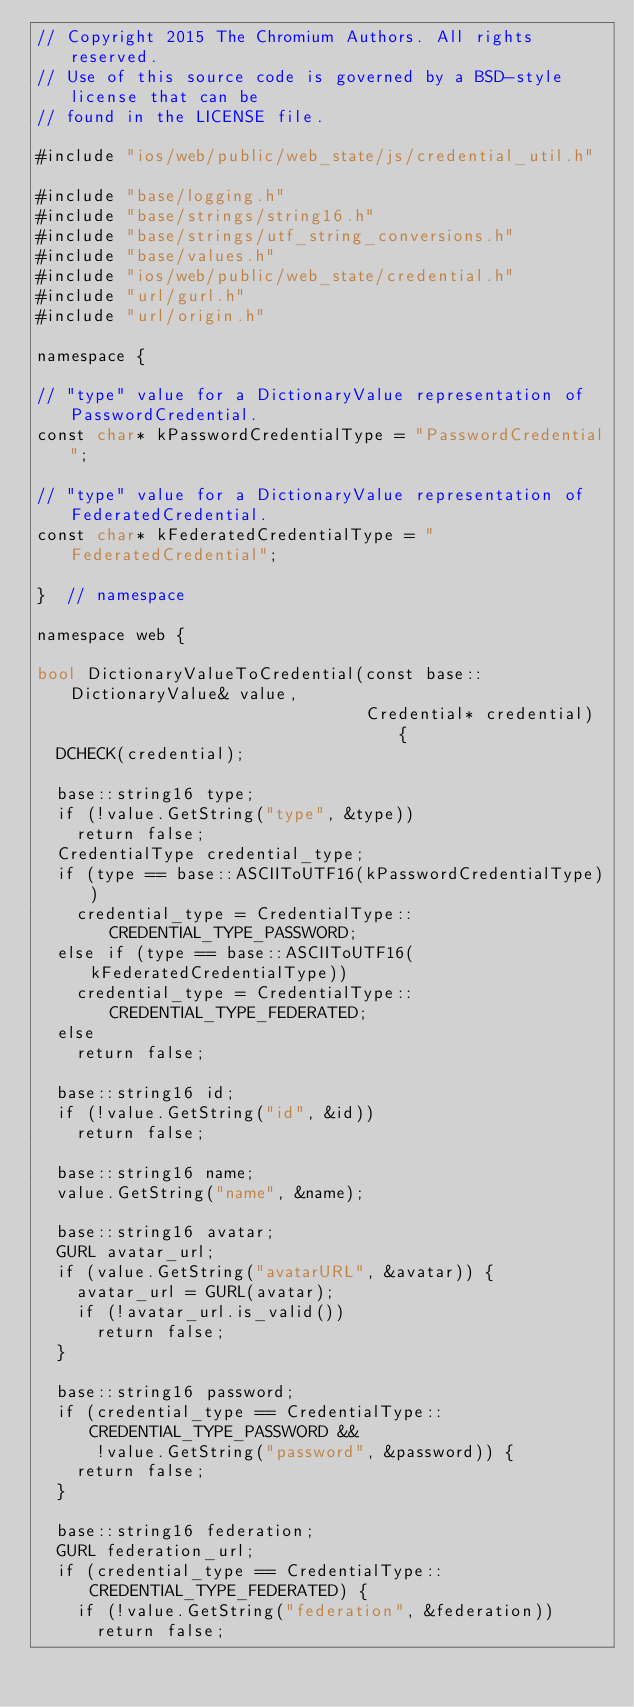<code> <loc_0><loc_0><loc_500><loc_500><_ObjectiveC_>// Copyright 2015 The Chromium Authors. All rights reserved.
// Use of this source code is governed by a BSD-style license that can be
// found in the LICENSE file.

#include "ios/web/public/web_state/js/credential_util.h"

#include "base/logging.h"
#include "base/strings/string16.h"
#include "base/strings/utf_string_conversions.h"
#include "base/values.h"
#include "ios/web/public/web_state/credential.h"
#include "url/gurl.h"
#include "url/origin.h"

namespace {

// "type" value for a DictionaryValue representation of PasswordCredential.
const char* kPasswordCredentialType = "PasswordCredential";

// "type" value for a DictionaryValue representation of FederatedCredential.
const char* kFederatedCredentialType = "FederatedCredential";

}  // namespace

namespace web {

bool DictionaryValueToCredential(const base::DictionaryValue& value,
                                 Credential* credential) {
  DCHECK(credential);

  base::string16 type;
  if (!value.GetString("type", &type))
    return false;
  CredentialType credential_type;
  if (type == base::ASCIIToUTF16(kPasswordCredentialType))
    credential_type = CredentialType::CREDENTIAL_TYPE_PASSWORD;
  else if (type == base::ASCIIToUTF16(kFederatedCredentialType))
    credential_type = CredentialType::CREDENTIAL_TYPE_FEDERATED;
  else
    return false;

  base::string16 id;
  if (!value.GetString("id", &id))
    return false;

  base::string16 name;
  value.GetString("name", &name);

  base::string16 avatar;
  GURL avatar_url;
  if (value.GetString("avatarURL", &avatar)) {
    avatar_url = GURL(avatar);
    if (!avatar_url.is_valid())
      return false;
  }

  base::string16 password;
  if (credential_type == CredentialType::CREDENTIAL_TYPE_PASSWORD &&
      !value.GetString("password", &password)) {
    return false;
  }

  base::string16 federation;
  GURL federation_url;
  if (credential_type == CredentialType::CREDENTIAL_TYPE_FEDERATED) {
    if (!value.GetString("federation", &federation))
      return false;</code> 